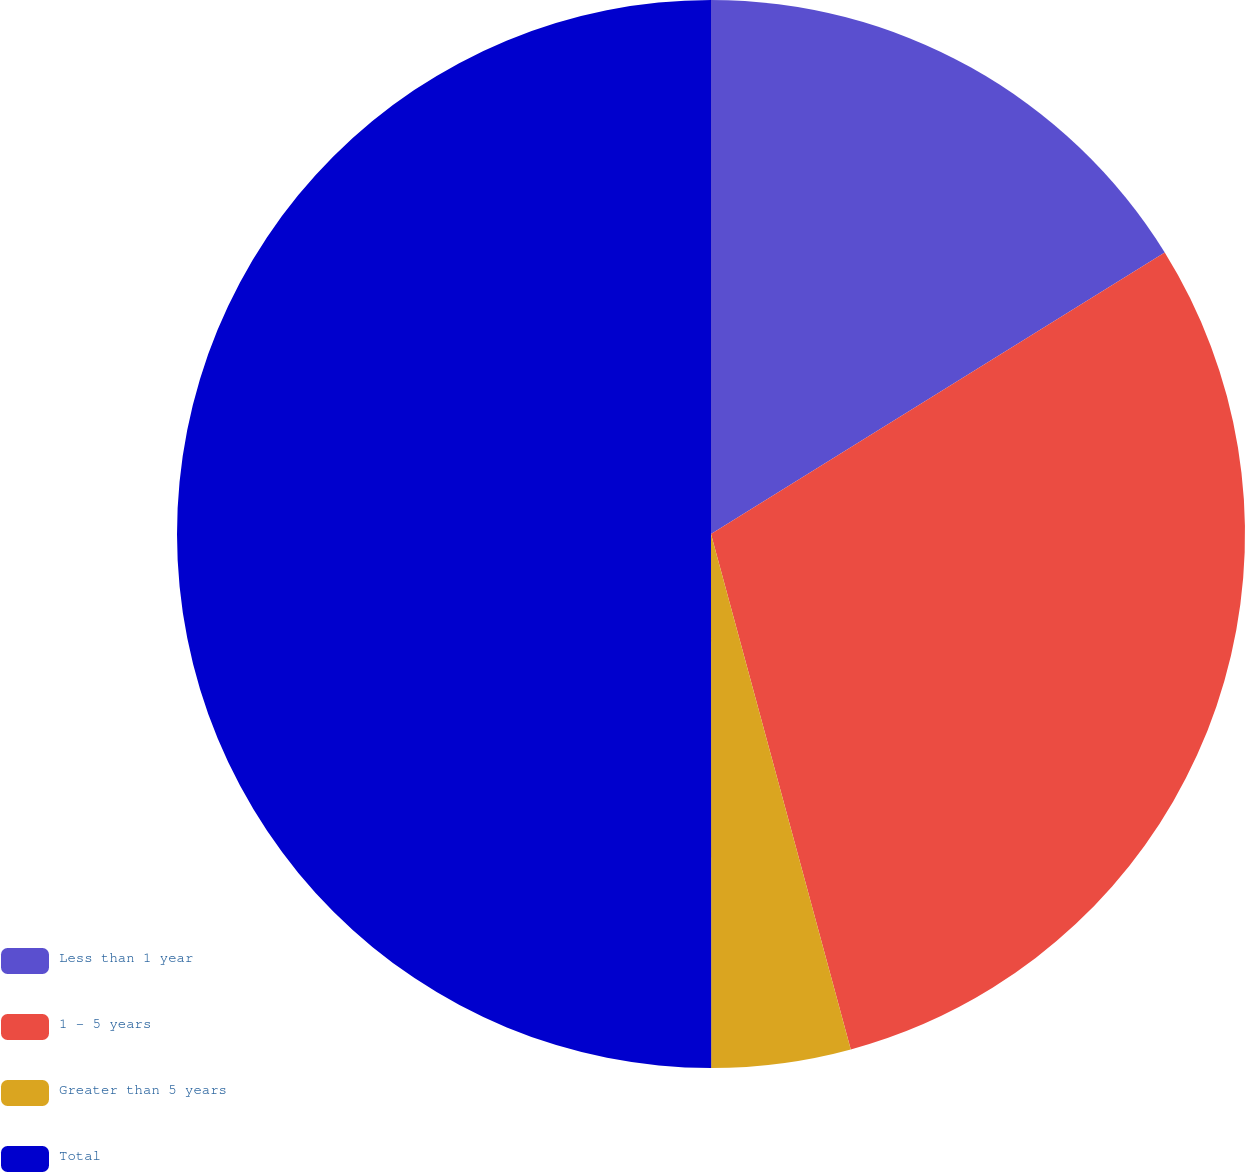Convert chart to OTSL. <chart><loc_0><loc_0><loc_500><loc_500><pie_chart><fcel>Less than 1 year<fcel>1 - 5 years<fcel>Greater than 5 years<fcel>Total<nl><fcel>16.16%<fcel>29.62%<fcel>4.21%<fcel>50.0%<nl></chart> 